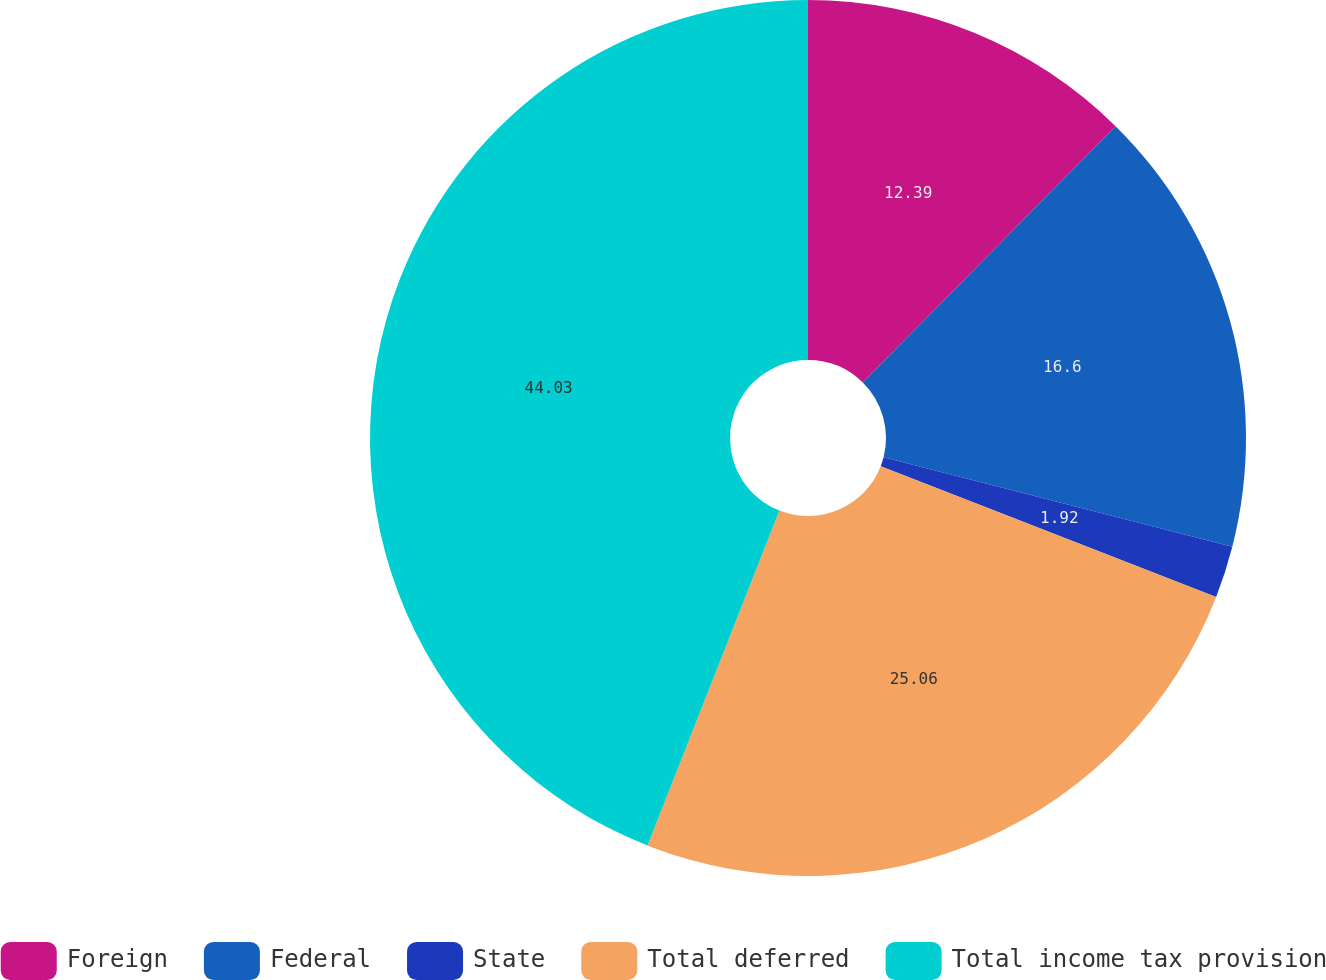<chart> <loc_0><loc_0><loc_500><loc_500><pie_chart><fcel>Foreign<fcel>Federal<fcel>State<fcel>Total deferred<fcel>Total income tax provision<nl><fcel>12.39%<fcel>16.6%<fcel>1.92%<fcel>25.06%<fcel>44.03%<nl></chart> 